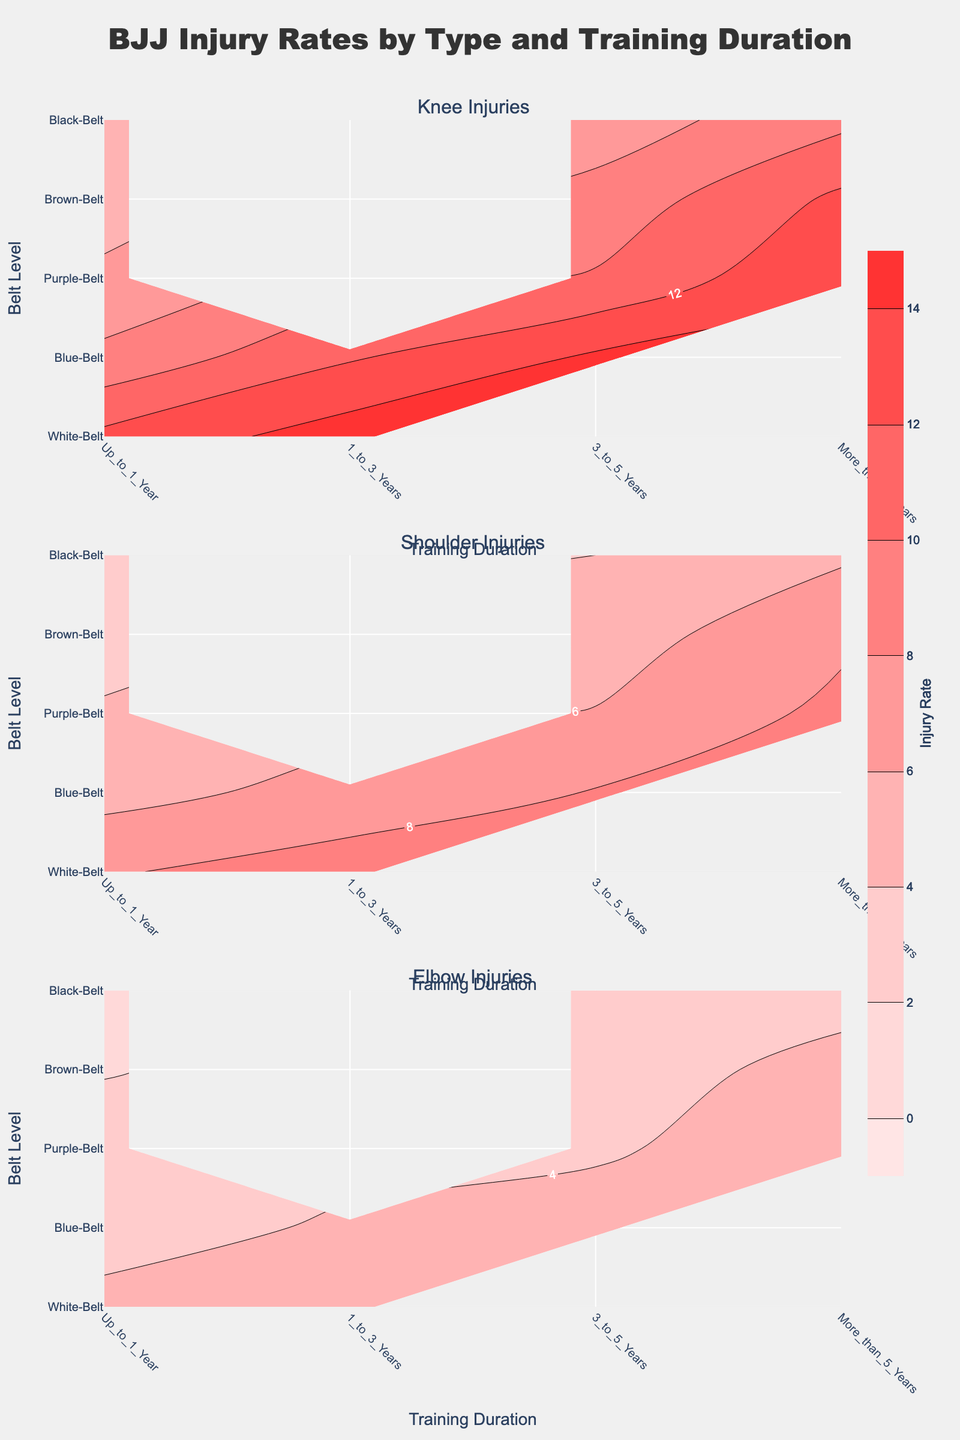What is the title of the figure? The title is located at the top center of the figure. It summarizes the purpose of the chart by describing what the chart depicts.
Answer: BJJ Injury Rates by Type and Training Duration What are the titles of the subplots? The subplot titles are located above each subplot, indicating the type of injury each subplot is related to.
Answer: Knee Injuries, Shoulder Injuries, Elbow Injuries Which belt level and training duration combination has the highest knee injury rate? By inspecting the contour plot for knee injuries, look for the highest contour label or darkest shade. The highest rate is often marked with labels in the contour plot.
Answer: White-Belt, 1 to 3 Years How does the injury rate for shoulder injuries compare between Blue-Belt and Black-Belt with More than 5 Years of training? Compare the contour labels or shades in the shoulder injury subplot for Blue-Belt and Black-Belt under the 'More than 5 Years' training duration.
Answer: Blue-Belt has a higher rate What is the overall trend in knee injury rates as training duration increases for Purple-Belts? Look at the Purple-Belt row in the knee injuries subplot and observe how the contour levels or colors change from 'Up to 1 Year' to 'More than 5 Years'.
Answer: The rate increases What is the difference in elbow injury rates between White-Belts with 1 to 3 Years and Brown-Belts with More than 5 Years? Find and subtract the contour value for elbow injuries under White-Belts with 1 to 3 Years from the contour value for Brown-Belts with More than 5 Years.
Answer: 0.8 Which belt level has the lowest injury rate for shoulder injuries within Up to 1 Year of training? Inspect the contour plot for shoulder injuries and find the belt level corresponding to the lightest shade or lowest contour label under 'Up to 1 Year' training duration.
Answer: Black-Belt What can be inferred about the elbow injury rate trend across different belt levels for those with More than 5 Years of training? Observe the contour levels or colors in the elbow injury subplot across all belt levels for 'More than 5 Years'. Note how the values change.
Answer: The rate generally increases How do the knee injury rates vary for Blue-Belts as they gain more training experience from Up to 1 Year to 3 to 5 Years? Follow the contours for Blue-Belts in the knee injuries subplot from 'Up to 1 Year' to '3 to 5 Years' and note the trends.
Answer: They increase Which training duration has the highest average injury rate for shoulder injuries across all belt levels? Calculate the average shoulder injury rate within each training duration by summing the contour values for all belt levels and dividing by the number of belt levels. The duration with the highest average is the answer.
Answer: More than 5 Years 